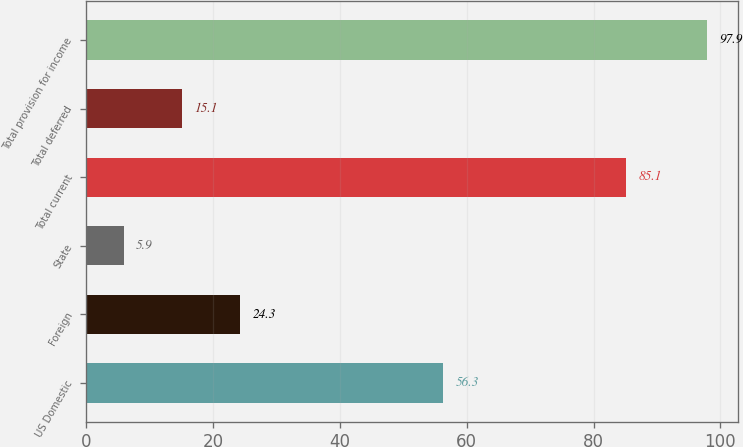Convert chart to OTSL. <chart><loc_0><loc_0><loc_500><loc_500><bar_chart><fcel>US Domestic<fcel>Foreign<fcel>State<fcel>Total current<fcel>Total deferred<fcel>Total provision for income<nl><fcel>56.3<fcel>24.3<fcel>5.9<fcel>85.1<fcel>15.1<fcel>97.9<nl></chart> 